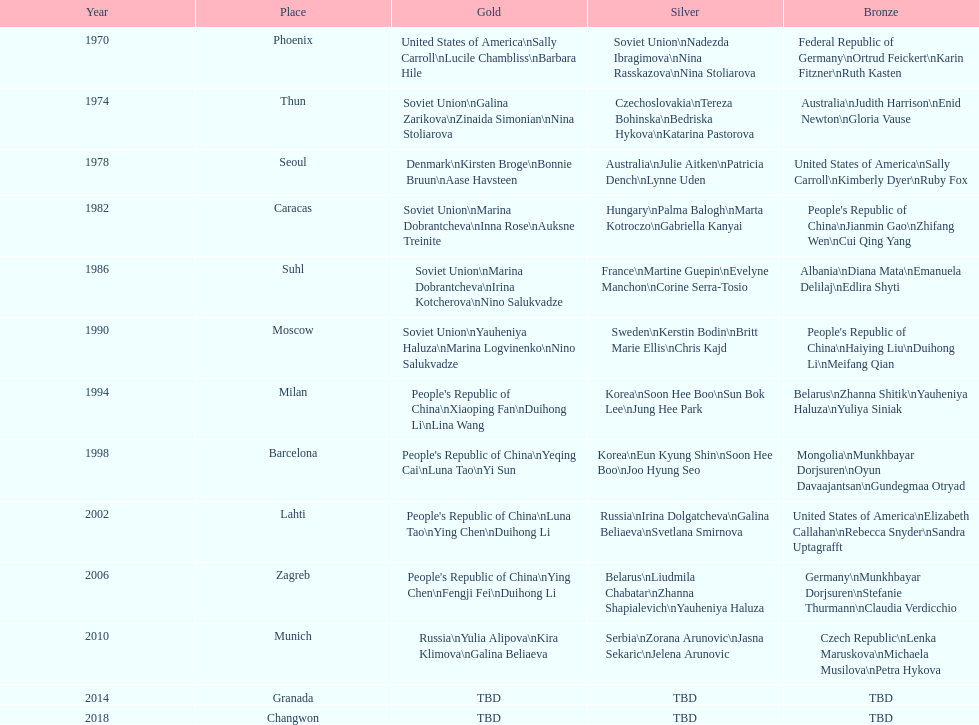What is the complete sum of instances where the soviet union is featured in the gold column? 4. 